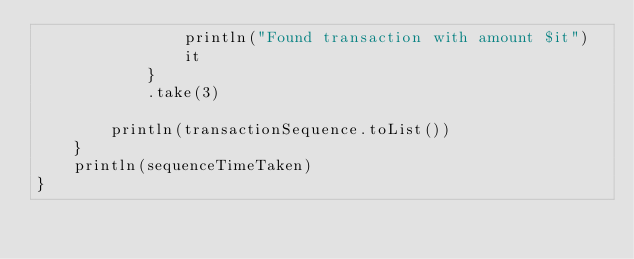Convert code to text. <code><loc_0><loc_0><loc_500><loc_500><_Kotlin_>                println("Found transaction with amount $it")
                it
            }
            .take(3)

        println(transactionSequence.toList())
    }
    println(sequenceTimeTaken)
}</code> 